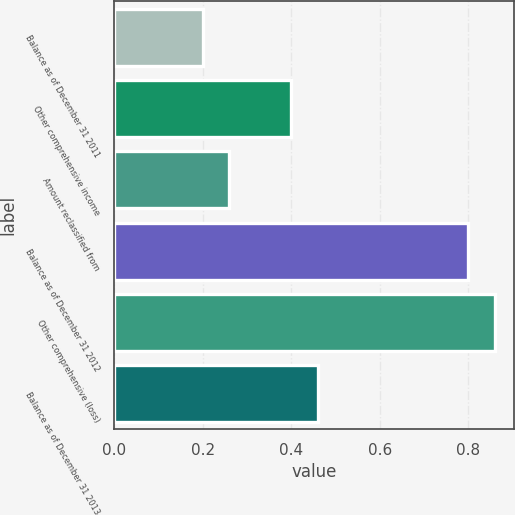Convert chart to OTSL. <chart><loc_0><loc_0><loc_500><loc_500><bar_chart><fcel>Balance as of December 31 2011<fcel>Other comprehensive income<fcel>Amount reclassified from<fcel>Balance as of December 31 2012<fcel>Other comprehensive (loss)<fcel>Balance as of December 31 2013<nl><fcel>0.2<fcel>0.4<fcel>0.26<fcel>0.8<fcel>0.86<fcel>0.46<nl></chart> 